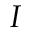Convert formula to latex. <formula><loc_0><loc_0><loc_500><loc_500>I</formula> 